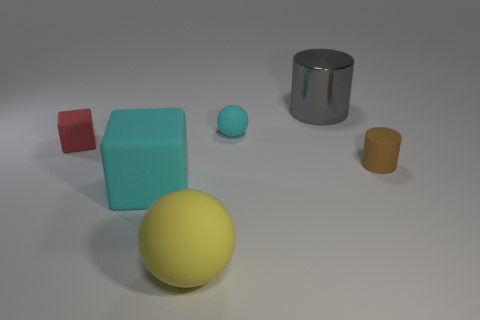Are there any rubber balls of the same size as the cyan rubber block?
Offer a very short reply. Yes. How many things are blocks or tiny rubber cylinders?
Keep it short and to the point. 3. Is the size of the matte sphere that is behind the big yellow sphere the same as the gray metal object that is behind the large yellow matte object?
Keep it short and to the point. No. Are there any other red metallic objects of the same shape as the metal thing?
Keep it short and to the point. No. Is the number of big metal objects that are in front of the brown rubber cylinder less than the number of tiny red matte cubes?
Your response must be concise. Yes. Is the shape of the metallic object the same as the large cyan object?
Give a very brief answer. No. What is the size of the cyan matte object on the right side of the large ball?
Give a very brief answer. Small. There is a brown cylinder that is made of the same material as the small red cube; what is its size?
Provide a succinct answer. Small. Are there fewer big green cubes than small cyan matte things?
Provide a short and direct response. Yes. What is the material of the cube that is the same size as the yellow rubber thing?
Give a very brief answer. Rubber. 